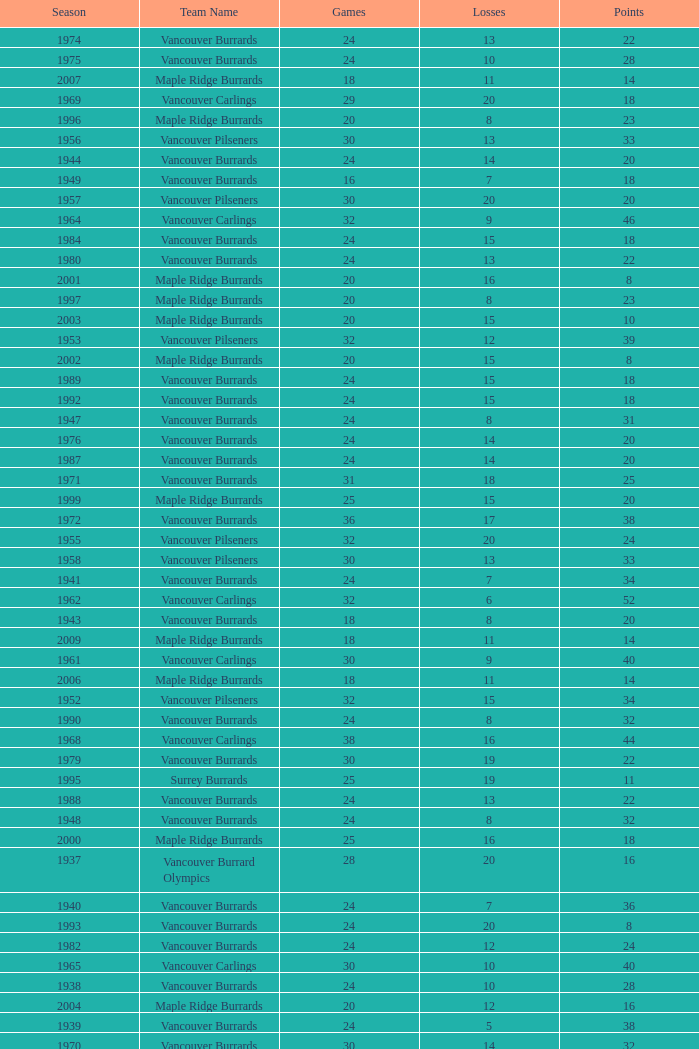What's the total number of points when the vancouver carlings have fewer than 12 losses and more than 32 games? 0.0. 